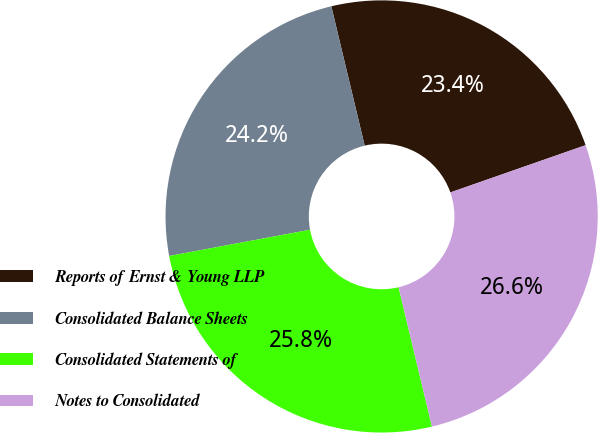Convert chart. <chart><loc_0><loc_0><loc_500><loc_500><pie_chart><fcel>Reports of Ernst & Young LLP<fcel>Consolidated Balance Sheets<fcel>Consolidated Statements of<fcel>Notes to Consolidated<nl><fcel>23.39%<fcel>24.19%<fcel>25.81%<fcel>26.61%<nl></chart> 